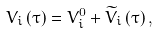<formula> <loc_0><loc_0><loc_500><loc_500>V _ { i } \left ( \tau \right ) = V _ { i } ^ { 0 } + \widetilde { V } _ { i } \left ( \tau \right ) ,</formula> 